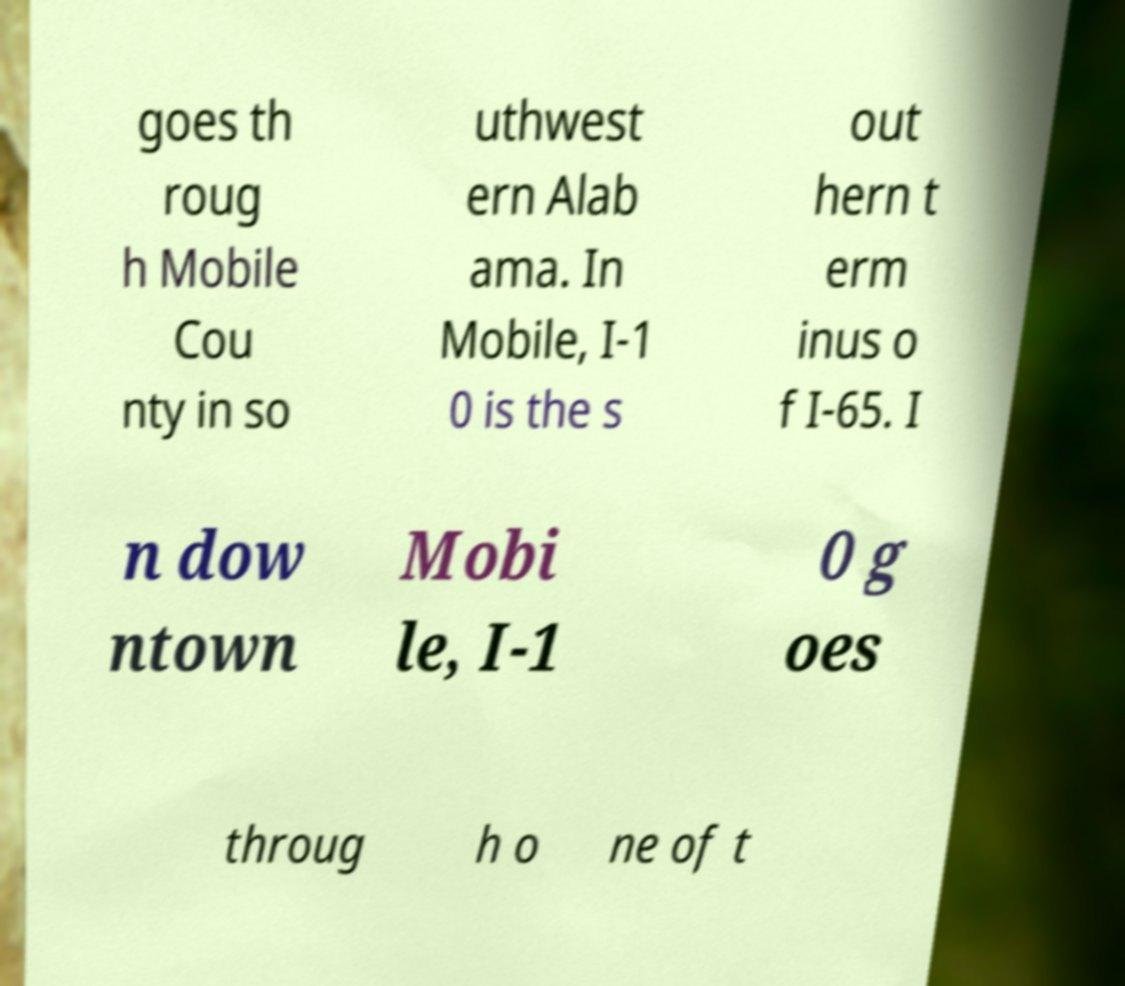What messages or text are displayed in this image? I need them in a readable, typed format. goes th roug h Mobile Cou nty in so uthwest ern Alab ama. In Mobile, I-1 0 is the s out hern t erm inus o f I-65. I n dow ntown Mobi le, I-1 0 g oes throug h o ne of t 